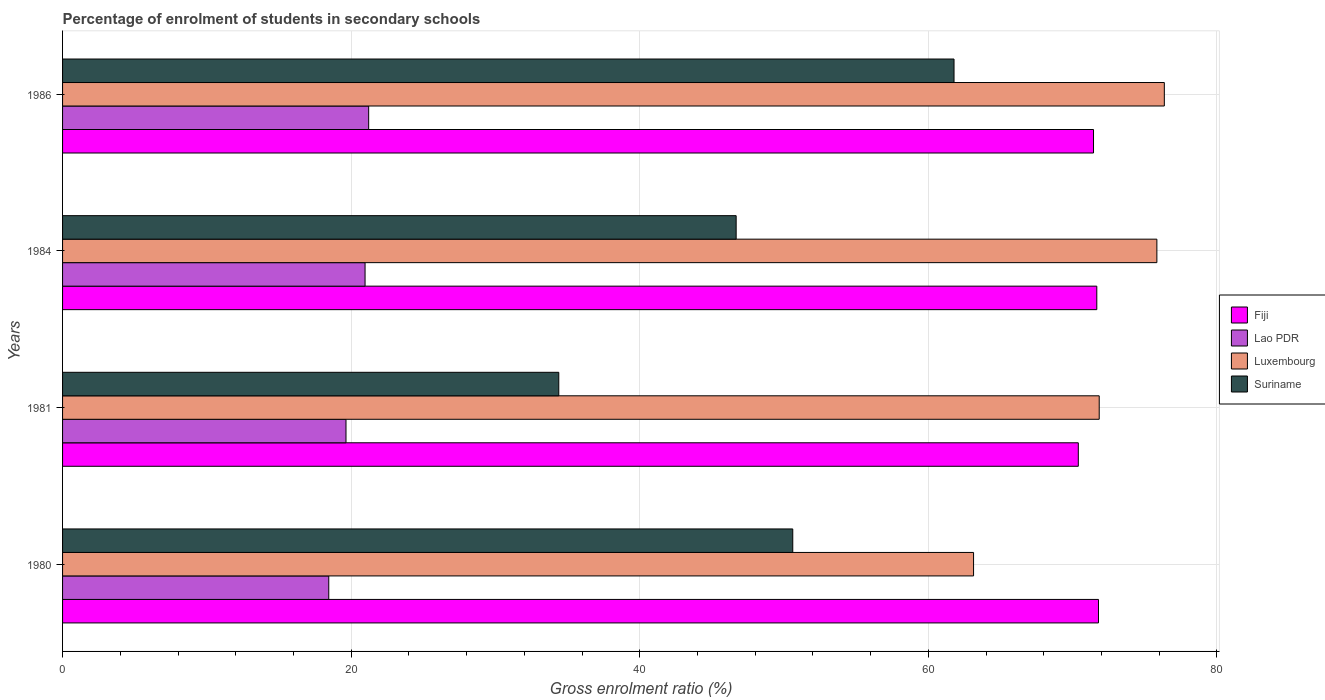Are the number of bars per tick equal to the number of legend labels?
Your response must be concise. Yes. How many bars are there on the 3rd tick from the top?
Give a very brief answer. 4. How many bars are there on the 3rd tick from the bottom?
Give a very brief answer. 4. In how many cases, is the number of bars for a given year not equal to the number of legend labels?
Keep it short and to the point. 0. What is the percentage of students enrolled in secondary schools in Fiji in 1984?
Make the answer very short. 71.68. Across all years, what is the maximum percentage of students enrolled in secondary schools in Luxembourg?
Make the answer very short. 76.35. Across all years, what is the minimum percentage of students enrolled in secondary schools in Luxembourg?
Your response must be concise. 63.13. What is the total percentage of students enrolled in secondary schools in Lao PDR in the graph?
Ensure brevity in your answer.  80.27. What is the difference between the percentage of students enrolled in secondary schools in Lao PDR in 1984 and that in 1986?
Give a very brief answer. -0.25. What is the difference between the percentage of students enrolled in secondary schools in Lao PDR in 1981 and the percentage of students enrolled in secondary schools in Suriname in 1986?
Offer a very short reply. -42.14. What is the average percentage of students enrolled in secondary schools in Fiji per year?
Offer a terse response. 71.33. In the year 1981, what is the difference between the percentage of students enrolled in secondary schools in Luxembourg and percentage of students enrolled in secondary schools in Suriname?
Make the answer very short. 37.45. In how many years, is the percentage of students enrolled in secondary schools in Lao PDR greater than 64 %?
Ensure brevity in your answer.  0. What is the ratio of the percentage of students enrolled in secondary schools in Fiji in 1984 to that in 1986?
Your answer should be very brief. 1. Is the percentage of students enrolled in secondary schools in Fiji in 1984 less than that in 1986?
Offer a very short reply. No. What is the difference between the highest and the second highest percentage of students enrolled in secondary schools in Luxembourg?
Your response must be concise. 0.52. What is the difference between the highest and the lowest percentage of students enrolled in secondary schools in Lao PDR?
Offer a very short reply. 2.77. Is it the case that in every year, the sum of the percentage of students enrolled in secondary schools in Luxembourg and percentage of students enrolled in secondary schools in Fiji is greater than the sum of percentage of students enrolled in secondary schools in Lao PDR and percentage of students enrolled in secondary schools in Suriname?
Give a very brief answer. Yes. What does the 3rd bar from the top in 1984 represents?
Provide a short and direct response. Lao PDR. What does the 3rd bar from the bottom in 1981 represents?
Make the answer very short. Luxembourg. What is the difference between two consecutive major ticks on the X-axis?
Provide a short and direct response. 20. Are the values on the major ticks of X-axis written in scientific E-notation?
Your response must be concise. No. Does the graph contain grids?
Provide a short and direct response. Yes. Where does the legend appear in the graph?
Give a very brief answer. Center right. How many legend labels are there?
Your response must be concise. 4. What is the title of the graph?
Give a very brief answer. Percentage of enrolment of students in secondary schools. Does "Iraq" appear as one of the legend labels in the graph?
Give a very brief answer. No. What is the label or title of the X-axis?
Ensure brevity in your answer.  Gross enrolment ratio (%). What is the label or title of the Y-axis?
Offer a terse response. Years. What is the Gross enrolment ratio (%) of Fiji in 1980?
Make the answer very short. 71.79. What is the Gross enrolment ratio (%) of Lao PDR in 1980?
Your response must be concise. 18.45. What is the Gross enrolment ratio (%) of Luxembourg in 1980?
Give a very brief answer. 63.13. What is the Gross enrolment ratio (%) of Suriname in 1980?
Your answer should be compact. 50.61. What is the Gross enrolment ratio (%) of Fiji in 1981?
Offer a very short reply. 70.39. What is the Gross enrolment ratio (%) in Lao PDR in 1981?
Provide a succinct answer. 19.64. What is the Gross enrolment ratio (%) of Luxembourg in 1981?
Ensure brevity in your answer.  71.84. What is the Gross enrolment ratio (%) of Suriname in 1981?
Your response must be concise. 34.39. What is the Gross enrolment ratio (%) of Fiji in 1984?
Give a very brief answer. 71.68. What is the Gross enrolment ratio (%) in Lao PDR in 1984?
Your answer should be very brief. 20.96. What is the Gross enrolment ratio (%) in Luxembourg in 1984?
Keep it short and to the point. 75.84. What is the Gross enrolment ratio (%) in Suriname in 1984?
Offer a very short reply. 46.68. What is the Gross enrolment ratio (%) of Fiji in 1986?
Ensure brevity in your answer.  71.45. What is the Gross enrolment ratio (%) of Lao PDR in 1986?
Your answer should be very brief. 21.21. What is the Gross enrolment ratio (%) in Luxembourg in 1986?
Offer a terse response. 76.35. What is the Gross enrolment ratio (%) of Suriname in 1986?
Make the answer very short. 61.78. Across all years, what is the maximum Gross enrolment ratio (%) of Fiji?
Offer a very short reply. 71.79. Across all years, what is the maximum Gross enrolment ratio (%) of Lao PDR?
Make the answer very short. 21.21. Across all years, what is the maximum Gross enrolment ratio (%) in Luxembourg?
Ensure brevity in your answer.  76.35. Across all years, what is the maximum Gross enrolment ratio (%) of Suriname?
Ensure brevity in your answer.  61.78. Across all years, what is the minimum Gross enrolment ratio (%) of Fiji?
Offer a terse response. 70.39. Across all years, what is the minimum Gross enrolment ratio (%) in Lao PDR?
Keep it short and to the point. 18.45. Across all years, what is the minimum Gross enrolment ratio (%) of Luxembourg?
Your answer should be compact. 63.13. Across all years, what is the minimum Gross enrolment ratio (%) in Suriname?
Your answer should be very brief. 34.39. What is the total Gross enrolment ratio (%) in Fiji in the graph?
Make the answer very short. 285.31. What is the total Gross enrolment ratio (%) of Lao PDR in the graph?
Offer a terse response. 80.27. What is the total Gross enrolment ratio (%) of Luxembourg in the graph?
Your answer should be very brief. 287.17. What is the total Gross enrolment ratio (%) in Suriname in the graph?
Give a very brief answer. 193.46. What is the difference between the Gross enrolment ratio (%) of Fiji in 1980 and that in 1981?
Give a very brief answer. 1.4. What is the difference between the Gross enrolment ratio (%) of Lao PDR in 1980 and that in 1981?
Provide a succinct answer. -1.19. What is the difference between the Gross enrolment ratio (%) in Luxembourg in 1980 and that in 1981?
Make the answer very short. -8.71. What is the difference between the Gross enrolment ratio (%) of Suriname in 1980 and that in 1981?
Give a very brief answer. 16.22. What is the difference between the Gross enrolment ratio (%) of Fiji in 1980 and that in 1984?
Offer a terse response. 0.12. What is the difference between the Gross enrolment ratio (%) of Lao PDR in 1980 and that in 1984?
Offer a very short reply. -2.52. What is the difference between the Gross enrolment ratio (%) of Luxembourg in 1980 and that in 1984?
Offer a terse response. -12.7. What is the difference between the Gross enrolment ratio (%) in Suriname in 1980 and that in 1984?
Your answer should be compact. 3.92. What is the difference between the Gross enrolment ratio (%) of Fiji in 1980 and that in 1986?
Provide a short and direct response. 0.34. What is the difference between the Gross enrolment ratio (%) of Lao PDR in 1980 and that in 1986?
Provide a succinct answer. -2.77. What is the difference between the Gross enrolment ratio (%) of Luxembourg in 1980 and that in 1986?
Make the answer very short. -13.22. What is the difference between the Gross enrolment ratio (%) in Suriname in 1980 and that in 1986?
Provide a succinct answer. -11.18. What is the difference between the Gross enrolment ratio (%) of Fiji in 1981 and that in 1984?
Offer a very short reply. -1.28. What is the difference between the Gross enrolment ratio (%) in Lao PDR in 1981 and that in 1984?
Keep it short and to the point. -1.32. What is the difference between the Gross enrolment ratio (%) in Luxembourg in 1981 and that in 1984?
Offer a very short reply. -4. What is the difference between the Gross enrolment ratio (%) of Suriname in 1981 and that in 1984?
Give a very brief answer. -12.29. What is the difference between the Gross enrolment ratio (%) in Fiji in 1981 and that in 1986?
Provide a short and direct response. -1.05. What is the difference between the Gross enrolment ratio (%) of Lao PDR in 1981 and that in 1986?
Your response must be concise. -1.57. What is the difference between the Gross enrolment ratio (%) of Luxembourg in 1981 and that in 1986?
Your response must be concise. -4.51. What is the difference between the Gross enrolment ratio (%) of Suriname in 1981 and that in 1986?
Provide a succinct answer. -27.39. What is the difference between the Gross enrolment ratio (%) in Fiji in 1984 and that in 1986?
Your response must be concise. 0.23. What is the difference between the Gross enrolment ratio (%) of Lao PDR in 1984 and that in 1986?
Your answer should be very brief. -0.25. What is the difference between the Gross enrolment ratio (%) in Luxembourg in 1984 and that in 1986?
Keep it short and to the point. -0.52. What is the difference between the Gross enrolment ratio (%) in Suriname in 1984 and that in 1986?
Offer a terse response. -15.1. What is the difference between the Gross enrolment ratio (%) of Fiji in 1980 and the Gross enrolment ratio (%) of Lao PDR in 1981?
Keep it short and to the point. 52.15. What is the difference between the Gross enrolment ratio (%) of Fiji in 1980 and the Gross enrolment ratio (%) of Luxembourg in 1981?
Your response must be concise. -0.05. What is the difference between the Gross enrolment ratio (%) of Fiji in 1980 and the Gross enrolment ratio (%) of Suriname in 1981?
Make the answer very short. 37.4. What is the difference between the Gross enrolment ratio (%) of Lao PDR in 1980 and the Gross enrolment ratio (%) of Luxembourg in 1981?
Give a very brief answer. -53.39. What is the difference between the Gross enrolment ratio (%) in Lao PDR in 1980 and the Gross enrolment ratio (%) in Suriname in 1981?
Ensure brevity in your answer.  -15.94. What is the difference between the Gross enrolment ratio (%) of Luxembourg in 1980 and the Gross enrolment ratio (%) of Suriname in 1981?
Provide a succinct answer. 28.75. What is the difference between the Gross enrolment ratio (%) of Fiji in 1980 and the Gross enrolment ratio (%) of Lao PDR in 1984?
Give a very brief answer. 50.83. What is the difference between the Gross enrolment ratio (%) of Fiji in 1980 and the Gross enrolment ratio (%) of Luxembourg in 1984?
Offer a terse response. -4.05. What is the difference between the Gross enrolment ratio (%) in Fiji in 1980 and the Gross enrolment ratio (%) in Suriname in 1984?
Provide a short and direct response. 25.11. What is the difference between the Gross enrolment ratio (%) of Lao PDR in 1980 and the Gross enrolment ratio (%) of Luxembourg in 1984?
Make the answer very short. -57.39. What is the difference between the Gross enrolment ratio (%) in Lao PDR in 1980 and the Gross enrolment ratio (%) in Suriname in 1984?
Your answer should be compact. -28.23. What is the difference between the Gross enrolment ratio (%) in Luxembourg in 1980 and the Gross enrolment ratio (%) in Suriname in 1984?
Make the answer very short. 16.45. What is the difference between the Gross enrolment ratio (%) of Fiji in 1980 and the Gross enrolment ratio (%) of Lao PDR in 1986?
Your answer should be very brief. 50.58. What is the difference between the Gross enrolment ratio (%) in Fiji in 1980 and the Gross enrolment ratio (%) in Luxembourg in 1986?
Ensure brevity in your answer.  -4.56. What is the difference between the Gross enrolment ratio (%) of Fiji in 1980 and the Gross enrolment ratio (%) of Suriname in 1986?
Offer a very short reply. 10.01. What is the difference between the Gross enrolment ratio (%) of Lao PDR in 1980 and the Gross enrolment ratio (%) of Luxembourg in 1986?
Your answer should be compact. -57.91. What is the difference between the Gross enrolment ratio (%) of Lao PDR in 1980 and the Gross enrolment ratio (%) of Suriname in 1986?
Ensure brevity in your answer.  -43.33. What is the difference between the Gross enrolment ratio (%) in Luxembourg in 1980 and the Gross enrolment ratio (%) in Suriname in 1986?
Offer a terse response. 1.35. What is the difference between the Gross enrolment ratio (%) in Fiji in 1981 and the Gross enrolment ratio (%) in Lao PDR in 1984?
Your answer should be very brief. 49.43. What is the difference between the Gross enrolment ratio (%) of Fiji in 1981 and the Gross enrolment ratio (%) of Luxembourg in 1984?
Make the answer very short. -5.44. What is the difference between the Gross enrolment ratio (%) of Fiji in 1981 and the Gross enrolment ratio (%) of Suriname in 1984?
Ensure brevity in your answer.  23.71. What is the difference between the Gross enrolment ratio (%) of Lao PDR in 1981 and the Gross enrolment ratio (%) of Luxembourg in 1984?
Provide a short and direct response. -56.2. What is the difference between the Gross enrolment ratio (%) in Lao PDR in 1981 and the Gross enrolment ratio (%) in Suriname in 1984?
Ensure brevity in your answer.  -27.04. What is the difference between the Gross enrolment ratio (%) of Luxembourg in 1981 and the Gross enrolment ratio (%) of Suriname in 1984?
Ensure brevity in your answer.  25.16. What is the difference between the Gross enrolment ratio (%) in Fiji in 1981 and the Gross enrolment ratio (%) in Lao PDR in 1986?
Offer a terse response. 49.18. What is the difference between the Gross enrolment ratio (%) of Fiji in 1981 and the Gross enrolment ratio (%) of Luxembourg in 1986?
Your answer should be very brief. -5.96. What is the difference between the Gross enrolment ratio (%) of Fiji in 1981 and the Gross enrolment ratio (%) of Suriname in 1986?
Provide a short and direct response. 8.61. What is the difference between the Gross enrolment ratio (%) in Lao PDR in 1981 and the Gross enrolment ratio (%) in Luxembourg in 1986?
Ensure brevity in your answer.  -56.71. What is the difference between the Gross enrolment ratio (%) in Lao PDR in 1981 and the Gross enrolment ratio (%) in Suriname in 1986?
Your response must be concise. -42.14. What is the difference between the Gross enrolment ratio (%) in Luxembourg in 1981 and the Gross enrolment ratio (%) in Suriname in 1986?
Give a very brief answer. 10.06. What is the difference between the Gross enrolment ratio (%) in Fiji in 1984 and the Gross enrolment ratio (%) in Lao PDR in 1986?
Keep it short and to the point. 50.46. What is the difference between the Gross enrolment ratio (%) of Fiji in 1984 and the Gross enrolment ratio (%) of Luxembourg in 1986?
Give a very brief answer. -4.68. What is the difference between the Gross enrolment ratio (%) in Fiji in 1984 and the Gross enrolment ratio (%) in Suriname in 1986?
Your answer should be compact. 9.89. What is the difference between the Gross enrolment ratio (%) of Lao PDR in 1984 and the Gross enrolment ratio (%) of Luxembourg in 1986?
Provide a short and direct response. -55.39. What is the difference between the Gross enrolment ratio (%) of Lao PDR in 1984 and the Gross enrolment ratio (%) of Suriname in 1986?
Provide a succinct answer. -40.82. What is the difference between the Gross enrolment ratio (%) in Luxembourg in 1984 and the Gross enrolment ratio (%) in Suriname in 1986?
Make the answer very short. 14.06. What is the average Gross enrolment ratio (%) in Fiji per year?
Your response must be concise. 71.33. What is the average Gross enrolment ratio (%) of Lao PDR per year?
Your answer should be compact. 20.07. What is the average Gross enrolment ratio (%) of Luxembourg per year?
Your answer should be very brief. 71.79. What is the average Gross enrolment ratio (%) of Suriname per year?
Make the answer very short. 48.36. In the year 1980, what is the difference between the Gross enrolment ratio (%) of Fiji and Gross enrolment ratio (%) of Lao PDR?
Offer a terse response. 53.34. In the year 1980, what is the difference between the Gross enrolment ratio (%) of Fiji and Gross enrolment ratio (%) of Luxembourg?
Offer a very short reply. 8.66. In the year 1980, what is the difference between the Gross enrolment ratio (%) in Fiji and Gross enrolment ratio (%) in Suriname?
Offer a terse response. 21.19. In the year 1980, what is the difference between the Gross enrolment ratio (%) in Lao PDR and Gross enrolment ratio (%) in Luxembourg?
Offer a very short reply. -44.69. In the year 1980, what is the difference between the Gross enrolment ratio (%) of Lao PDR and Gross enrolment ratio (%) of Suriname?
Offer a very short reply. -32.16. In the year 1980, what is the difference between the Gross enrolment ratio (%) in Luxembourg and Gross enrolment ratio (%) in Suriname?
Ensure brevity in your answer.  12.53. In the year 1981, what is the difference between the Gross enrolment ratio (%) in Fiji and Gross enrolment ratio (%) in Lao PDR?
Keep it short and to the point. 50.75. In the year 1981, what is the difference between the Gross enrolment ratio (%) in Fiji and Gross enrolment ratio (%) in Luxembourg?
Provide a short and direct response. -1.45. In the year 1981, what is the difference between the Gross enrolment ratio (%) in Fiji and Gross enrolment ratio (%) in Suriname?
Keep it short and to the point. 36.01. In the year 1981, what is the difference between the Gross enrolment ratio (%) of Lao PDR and Gross enrolment ratio (%) of Luxembourg?
Give a very brief answer. -52.2. In the year 1981, what is the difference between the Gross enrolment ratio (%) in Lao PDR and Gross enrolment ratio (%) in Suriname?
Provide a succinct answer. -14.75. In the year 1981, what is the difference between the Gross enrolment ratio (%) in Luxembourg and Gross enrolment ratio (%) in Suriname?
Provide a succinct answer. 37.45. In the year 1984, what is the difference between the Gross enrolment ratio (%) of Fiji and Gross enrolment ratio (%) of Lao PDR?
Offer a terse response. 50.71. In the year 1984, what is the difference between the Gross enrolment ratio (%) in Fiji and Gross enrolment ratio (%) in Luxembourg?
Your answer should be very brief. -4.16. In the year 1984, what is the difference between the Gross enrolment ratio (%) of Fiji and Gross enrolment ratio (%) of Suriname?
Provide a succinct answer. 24.99. In the year 1984, what is the difference between the Gross enrolment ratio (%) of Lao PDR and Gross enrolment ratio (%) of Luxembourg?
Provide a short and direct response. -54.87. In the year 1984, what is the difference between the Gross enrolment ratio (%) in Lao PDR and Gross enrolment ratio (%) in Suriname?
Provide a short and direct response. -25.72. In the year 1984, what is the difference between the Gross enrolment ratio (%) in Luxembourg and Gross enrolment ratio (%) in Suriname?
Ensure brevity in your answer.  29.16. In the year 1986, what is the difference between the Gross enrolment ratio (%) in Fiji and Gross enrolment ratio (%) in Lao PDR?
Your answer should be very brief. 50.23. In the year 1986, what is the difference between the Gross enrolment ratio (%) of Fiji and Gross enrolment ratio (%) of Luxembourg?
Provide a short and direct response. -4.91. In the year 1986, what is the difference between the Gross enrolment ratio (%) in Fiji and Gross enrolment ratio (%) in Suriname?
Provide a succinct answer. 9.67. In the year 1986, what is the difference between the Gross enrolment ratio (%) in Lao PDR and Gross enrolment ratio (%) in Luxembourg?
Offer a very short reply. -55.14. In the year 1986, what is the difference between the Gross enrolment ratio (%) of Lao PDR and Gross enrolment ratio (%) of Suriname?
Offer a terse response. -40.57. In the year 1986, what is the difference between the Gross enrolment ratio (%) of Luxembourg and Gross enrolment ratio (%) of Suriname?
Ensure brevity in your answer.  14.57. What is the ratio of the Gross enrolment ratio (%) in Fiji in 1980 to that in 1981?
Keep it short and to the point. 1.02. What is the ratio of the Gross enrolment ratio (%) in Lao PDR in 1980 to that in 1981?
Give a very brief answer. 0.94. What is the ratio of the Gross enrolment ratio (%) of Luxembourg in 1980 to that in 1981?
Provide a succinct answer. 0.88. What is the ratio of the Gross enrolment ratio (%) in Suriname in 1980 to that in 1981?
Your answer should be compact. 1.47. What is the ratio of the Gross enrolment ratio (%) in Fiji in 1980 to that in 1984?
Offer a terse response. 1. What is the ratio of the Gross enrolment ratio (%) of Luxembourg in 1980 to that in 1984?
Give a very brief answer. 0.83. What is the ratio of the Gross enrolment ratio (%) of Suriname in 1980 to that in 1984?
Your answer should be very brief. 1.08. What is the ratio of the Gross enrolment ratio (%) of Lao PDR in 1980 to that in 1986?
Provide a short and direct response. 0.87. What is the ratio of the Gross enrolment ratio (%) in Luxembourg in 1980 to that in 1986?
Offer a terse response. 0.83. What is the ratio of the Gross enrolment ratio (%) of Suriname in 1980 to that in 1986?
Provide a short and direct response. 0.82. What is the ratio of the Gross enrolment ratio (%) of Fiji in 1981 to that in 1984?
Keep it short and to the point. 0.98. What is the ratio of the Gross enrolment ratio (%) of Lao PDR in 1981 to that in 1984?
Provide a succinct answer. 0.94. What is the ratio of the Gross enrolment ratio (%) of Luxembourg in 1981 to that in 1984?
Provide a succinct answer. 0.95. What is the ratio of the Gross enrolment ratio (%) in Suriname in 1981 to that in 1984?
Make the answer very short. 0.74. What is the ratio of the Gross enrolment ratio (%) in Fiji in 1981 to that in 1986?
Provide a short and direct response. 0.99. What is the ratio of the Gross enrolment ratio (%) in Lao PDR in 1981 to that in 1986?
Provide a short and direct response. 0.93. What is the ratio of the Gross enrolment ratio (%) of Luxembourg in 1981 to that in 1986?
Ensure brevity in your answer.  0.94. What is the ratio of the Gross enrolment ratio (%) in Suriname in 1981 to that in 1986?
Your answer should be very brief. 0.56. What is the ratio of the Gross enrolment ratio (%) in Fiji in 1984 to that in 1986?
Your answer should be very brief. 1. What is the ratio of the Gross enrolment ratio (%) in Luxembourg in 1984 to that in 1986?
Your answer should be compact. 0.99. What is the ratio of the Gross enrolment ratio (%) in Suriname in 1984 to that in 1986?
Ensure brevity in your answer.  0.76. What is the difference between the highest and the second highest Gross enrolment ratio (%) in Fiji?
Give a very brief answer. 0.12. What is the difference between the highest and the second highest Gross enrolment ratio (%) of Lao PDR?
Offer a very short reply. 0.25. What is the difference between the highest and the second highest Gross enrolment ratio (%) of Luxembourg?
Your response must be concise. 0.52. What is the difference between the highest and the second highest Gross enrolment ratio (%) of Suriname?
Your answer should be very brief. 11.18. What is the difference between the highest and the lowest Gross enrolment ratio (%) of Fiji?
Your response must be concise. 1.4. What is the difference between the highest and the lowest Gross enrolment ratio (%) in Lao PDR?
Offer a terse response. 2.77. What is the difference between the highest and the lowest Gross enrolment ratio (%) of Luxembourg?
Your response must be concise. 13.22. What is the difference between the highest and the lowest Gross enrolment ratio (%) of Suriname?
Offer a terse response. 27.39. 